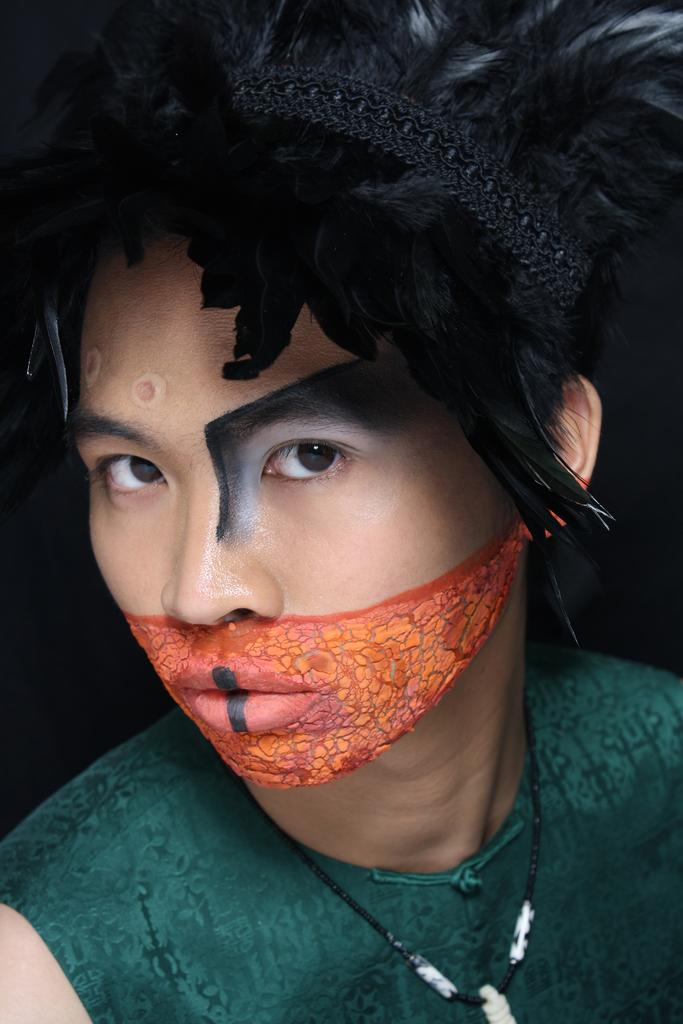What is the main subject of the image? There is a person in the image. What is the person wearing on their head? The person is wearing a feather crown. What is unique about the person's face? There is a painting on the face of the person. What type of truck can be seen in the background of the image? There is no truck visible in the image; it only features a person with a feather crown and a painted face. 